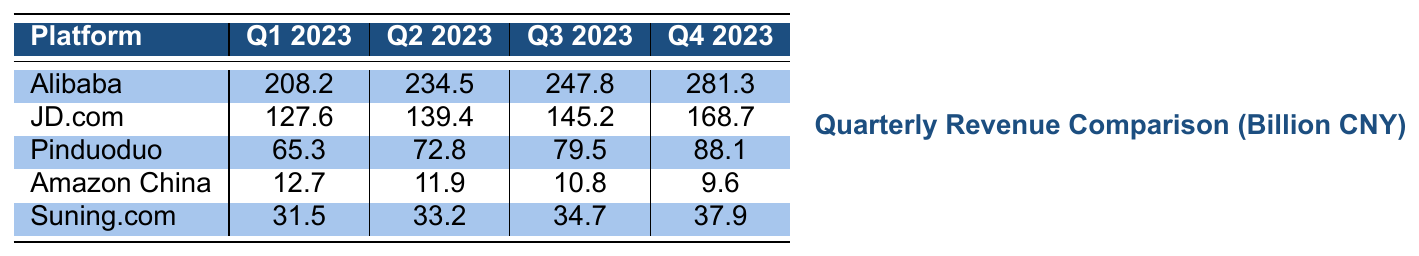What was Alibaba's revenue in Q4 2023? Referring to the table, Alibaba's revenue for Q4 2023 is specifically listed as 281.3 billion CNY.
Answer: 281.3 billion CNY Which platform had the lowest revenue in Q1 2023? Looking at the values in Q1 2023, Amazon China has the lowest revenue at 12.7 billion CNY.
Answer: Amazon China What is the total revenue of JD.com for all four quarters combined? By summing the revenues: 127.6 + 139.4 + 145.2 + 168.7 = 580.9 billion CNY, we find JD.com’s total revenue.
Answer: 580.9 billion CNY Did Amazon China experience an increase in revenue in any quarter compared to the previous quarter? Checking the numbers, Amazon China's revenues decreased from Q1 2023 (12.7 billion CNY) to Q4 2023 (9.6 billion CNY), confirming no increases in revenue over the quarters.
Answer: No What was the average revenue for Pinduoduo over the four quarters? Calculating the average involves summing the four quarters: 65.3 + 72.8 + 79.5 + 88.1 = 305.7, and dividing by 4, which equals 76.425 billion CNY.
Answer: 76.425 billion CNY By how much did Alibaba's revenue increase from Q1 to Q4 2023? The increase is calculated by subtracting Q1 revenue (208.2 billion CNY) from Q4 revenue (281.3 billion CNY), which gives an increase of 73.1 billion CNY.
Answer: 73.1 billion CNY Which platform showed the best growth percentage from Q1 to Q4 2023? For Alibaba, the growth percentage is [(281.3 - 208.2) / 208.2] * 100 ≈ 35.1%. JD.com’s is [(168.7 - 127.6) / 127.6] * 100 ≈ 32.2%. Pinduoduo's is [(88.1 - 65.3) / 65.3] * 100 ≈ 35%. Comparing these shows Alibaba has the highest growth percentage.
Answer: Alibaba What is the difference in revenue between JD.com and Suning.com in Q3 2023? In Q3 2023, JD.com earned 145.2 billion CNY while Suning.com earned 34.7 billion CNY. The difference is 145.2 - 34.7 = 110.5 billion CNY.
Answer: 110.5 billion CNY Is the revenue of Amazon China in Q2 2023 higher or lower than its revenue in Q3 2023? By comparing the values, Amazon China's revenue decreased from 11.9 billion CNY in Q2 2023 to 10.8 billion CNY in Q3 2023.
Answer: Lower Which platforms have revenues above 100 billion CNY in Q4 2023? By examining Q4 2023 figures, both Alibaba (281.3 billion CNY) and JD.com (168.7 billion CNY) exceed 100 billion CNY in revenue.
Answer: Alibaba and JD.com 